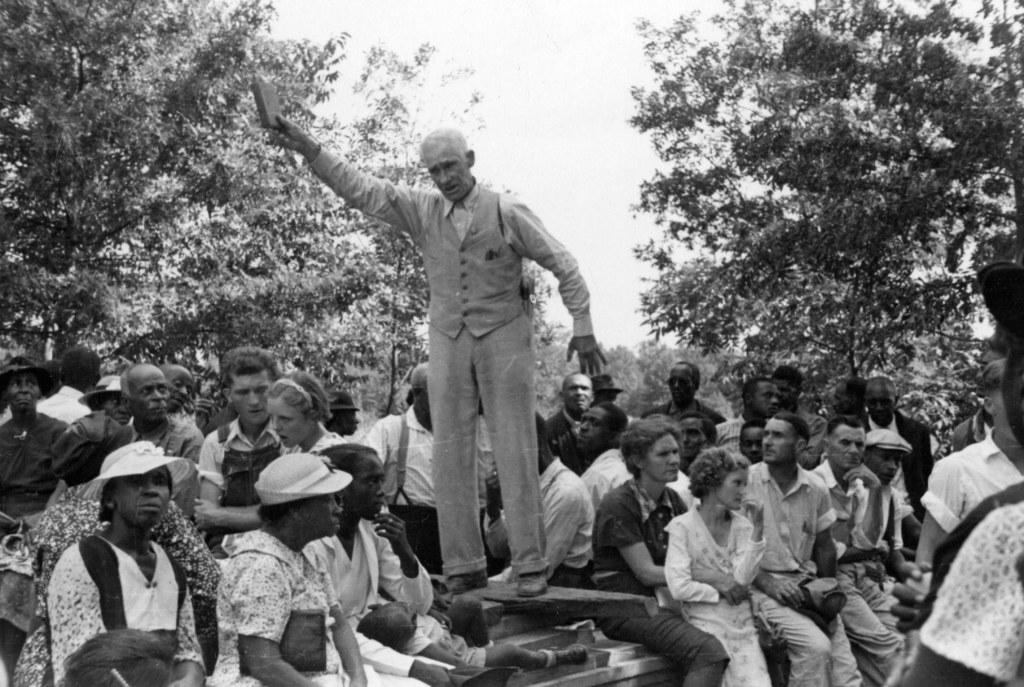What is the main subject of the image? There is a man in the image. What is the man doing in the image? The man is standing and holding a book. How many people are around the man? There are many people around the man. What can be seen in the background of the image? There are trees in the background of the image. What time does the clock in the image show? There is no clock present in the image. What type of medical treatment is the man receiving in the image? The image does not depict a hospital or any medical treatment; it shows a man standing and holding a book. 